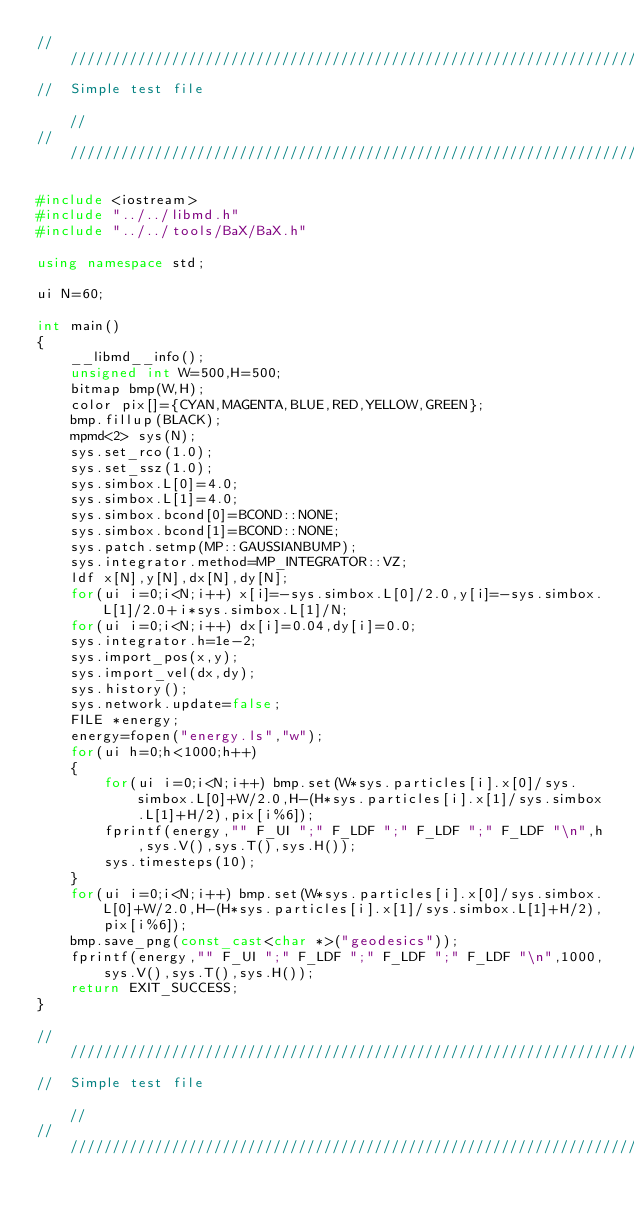Convert code to text. <code><loc_0><loc_0><loc_500><loc_500><_C++_>///////////////////////////////////////////////////////////////////////////////////////////////////////////////////
//  Simple test file                                                                                             //
///////////////////////////////////////////////////////////////////////////////////////////////////////////////////

#include <iostream>
#include "../../libmd.h"
#include "../../tools/BaX/BaX.h"

using namespace std;

ui N=60;

int main()
{
    __libmd__info();
    unsigned int W=500,H=500;
    bitmap bmp(W,H);
    color pix[]={CYAN,MAGENTA,BLUE,RED,YELLOW,GREEN};
    bmp.fillup(BLACK);
    mpmd<2> sys(N);
    sys.set_rco(1.0);
    sys.set_ssz(1.0);
    sys.simbox.L[0]=4.0;
    sys.simbox.L[1]=4.0;
    sys.simbox.bcond[0]=BCOND::NONE;
    sys.simbox.bcond[1]=BCOND::NONE;
    sys.patch.setmp(MP::GAUSSIANBUMP);
    sys.integrator.method=MP_INTEGRATOR::VZ;
    ldf x[N],y[N],dx[N],dy[N];
    for(ui i=0;i<N;i++) x[i]=-sys.simbox.L[0]/2.0,y[i]=-sys.simbox.L[1]/2.0+i*sys.simbox.L[1]/N;
    for(ui i=0;i<N;i++) dx[i]=0.04,dy[i]=0.0;
    sys.integrator.h=1e-2;
    sys.import_pos(x,y);
    sys.import_vel(dx,dy);
    sys.history();
    sys.network.update=false;
    FILE *energy;
    energy=fopen("energy.ls","w");
    for(ui h=0;h<1000;h++)
    {
        for(ui i=0;i<N;i++) bmp.set(W*sys.particles[i].x[0]/sys.simbox.L[0]+W/2.0,H-(H*sys.particles[i].x[1]/sys.simbox.L[1]+H/2),pix[i%6]);
        fprintf(energy,"" F_UI ";" F_LDF ";" F_LDF ";" F_LDF "\n",h,sys.V(),sys.T(),sys.H());
        sys.timesteps(10);
    }
    for(ui i=0;i<N;i++) bmp.set(W*sys.particles[i].x[0]/sys.simbox.L[0]+W/2.0,H-(H*sys.particles[i].x[1]/sys.simbox.L[1]+H/2),pix[i%6]);
    bmp.save_png(const_cast<char *>("geodesics"));
    fprintf(energy,"" F_UI ";" F_LDF ";" F_LDF ";" F_LDF "\n",1000,sys.V(),sys.T(),sys.H());
    return EXIT_SUCCESS;
}

///////////////////////////////////////////////////////////////////////////////////////////////////////////////////
//  Simple test file                                                                                             //
///////////////////////////////////////////////////////////////////////////////////////////////////////////////////
</code> 